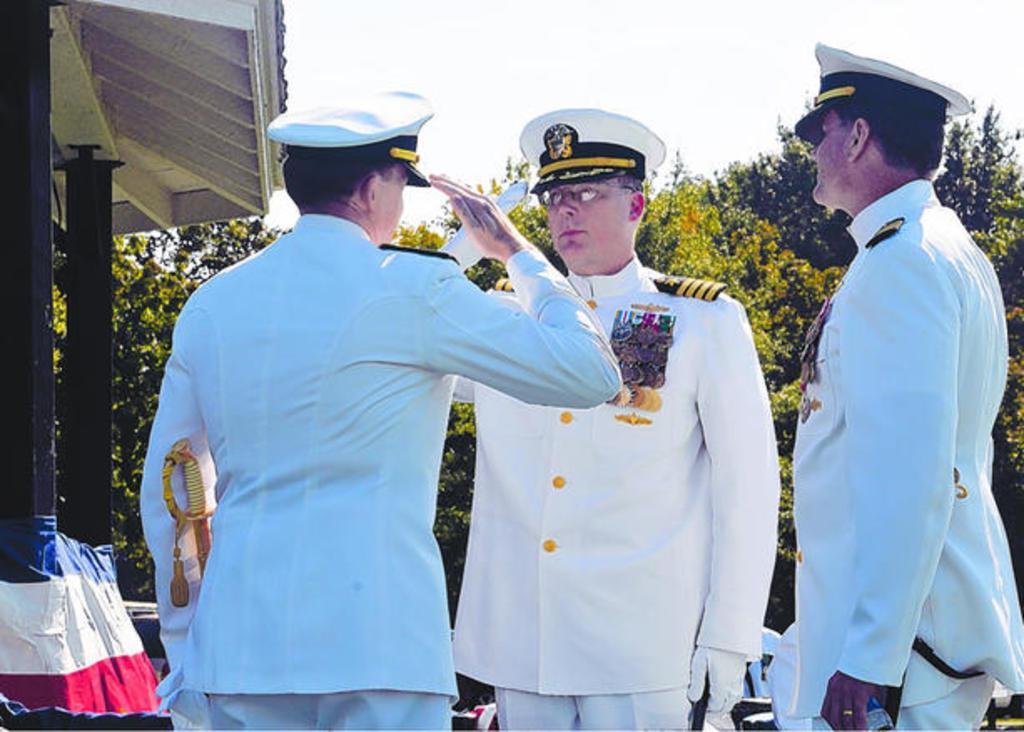In one or two sentences, can you explain what this image depicts? In this picture there are three officers wearing white cap, shirt, gloves and trouser. On the left there is a shed. In the bottom left corner there is a flag which is placed near to the pillars. In the background I can see the trees. At the top I can see the sky and clouds. 